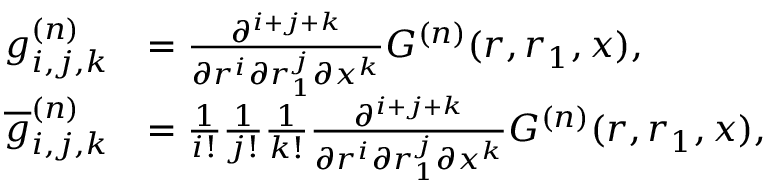<formula> <loc_0><loc_0><loc_500><loc_500>\begin{array} { r l } { g _ { i , j , k } ^ { ( n ) } } & { = \frac { \partial ^ { i + j + k } } { \partial r ^ { i } \partial r _ { 1 } ^ { j } \partial x ^ { k } } G ^ { ( n ) } ( r , r _ { 1 } , x ) , } \\ { \overline { g } _ { i , j , k } ^ { ( n ) } } & { = \frac { 1 } { i ! } \frac { 1 } { j ! } \frac { 1 } { k ! } \frac { \partial ^ { i + j + k } } { \partial r ^ { i } \partial r _ { 1 } ^ { j } \partial x ^ { k } } G ^ { ( n ) } ( r , r _ { 1 } , x ) , } \end{array}</formula> 